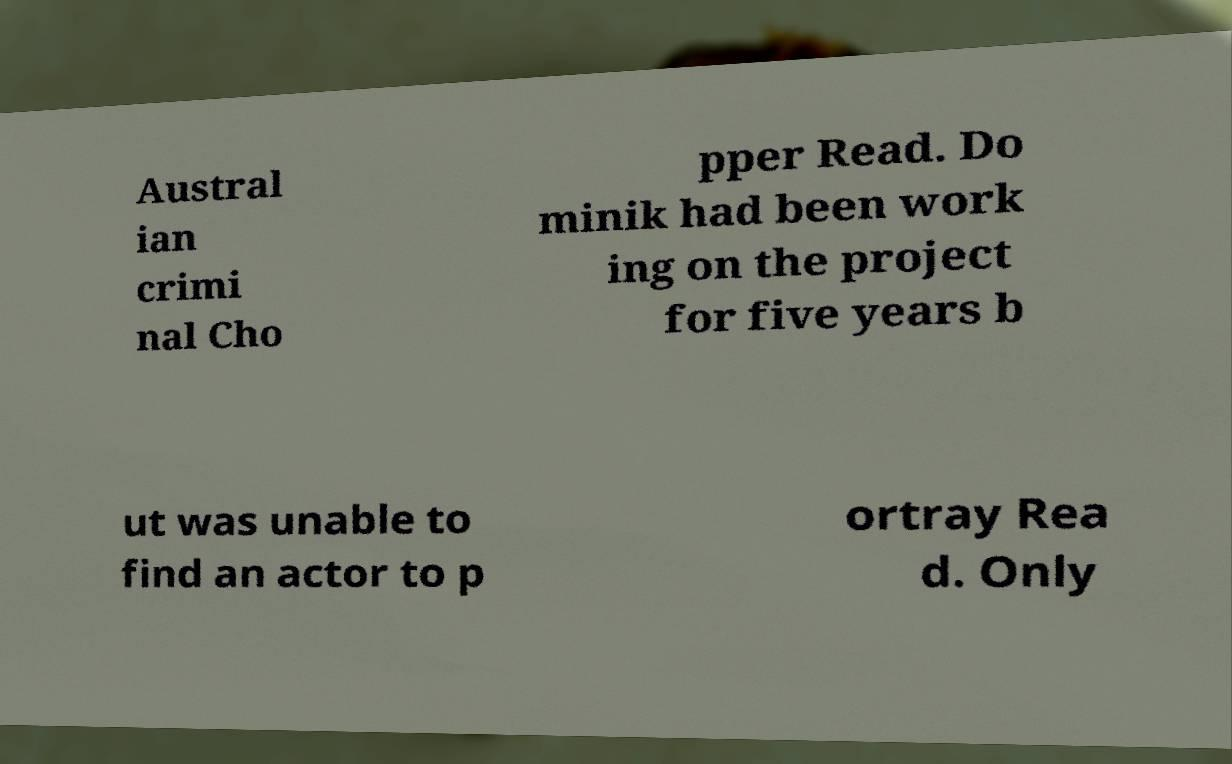Please read and relay the text visible in this image. What does it say? Austral ian crimi nal Cho pper Read. Do minik had been work ing on the project for five years b ut was unable to find an actor to p ortray Rea d. Only 